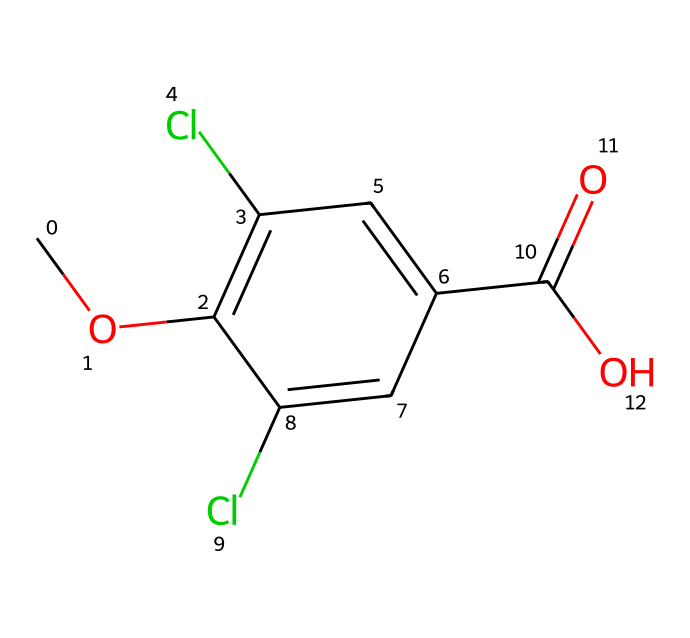What is the molecular formula of dicamba? To determine the molecular formula, we need to identify the number of each type of atom from the SMILES representation. The SMILES is COc1c(Cl)cc(cc1Cl)C(=O)O, which indicates a structure with carbon (C), hydrogen (H), chlorine (Cl), and oxygen (O). Counting the atoms gives us: 8 carbons, 7 hydrogens, 2 chlorines, and 3 oxygens. Therefore, the molecular formula is C8H7Cl2O3.
Answer: C8H7Cl2O3 How many chlorine atoms are in the structure? By looking at the SMILES representation, we see two instances of 'Cl' which denote chlorine atoms. This tells us that there are two chlorine atoms present in the structure.
Answer: 2 What functional groups are present in dicamba? Analyzing the structure, we can identify key functional groups. The first is the methoxy group (–OCH3) which is indicated by 'CO', and the second is the carboxylic acid group (–COOH) indicated by 'C(=O)O'. Therefore, the functional groups present are methoxy and carboxylic acid.
Answer: methoxy and carboxylic acid What is the significance of the carboxylic acid group in herbicides? The carboxylic acid group contributes to the polar nature of dicamba, enhancing its solubility in water, which is essential for its effectiveness as an herbicide in soil. This group also plays a role in the herbicide's interaction with plant biochemistry, leading to its herbicidal activity.
Answer: enhances solubility What type of herbicide is dicamba? Dicamba is classified as a broadleaf herbicide, which means it is specifically designed to target and control broadleaf weeds while minimizing harm to grasses. This specificity is due to its structural compatibility with certain biochemical pathways in plants.
Answer: broadleaf herbicide How many rings are in the chemical structure of dicamba? In the provided SMILES, 'c' designates aromatic carbon atoms. The presence of 'c1' and recurring 'c' indicates there is one aromatic ring in the structure. Thus, there is one ring in the chemical structure of dicamba.
Answer: 1 